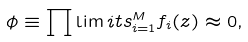<formula> <loc_0><loc_0><loc_500><loc_500>\phi \equiv \prod \lim i t s _ { i = 1 } ^ { M } f _ { i } ( z ) \approx 0 ,</formula> 